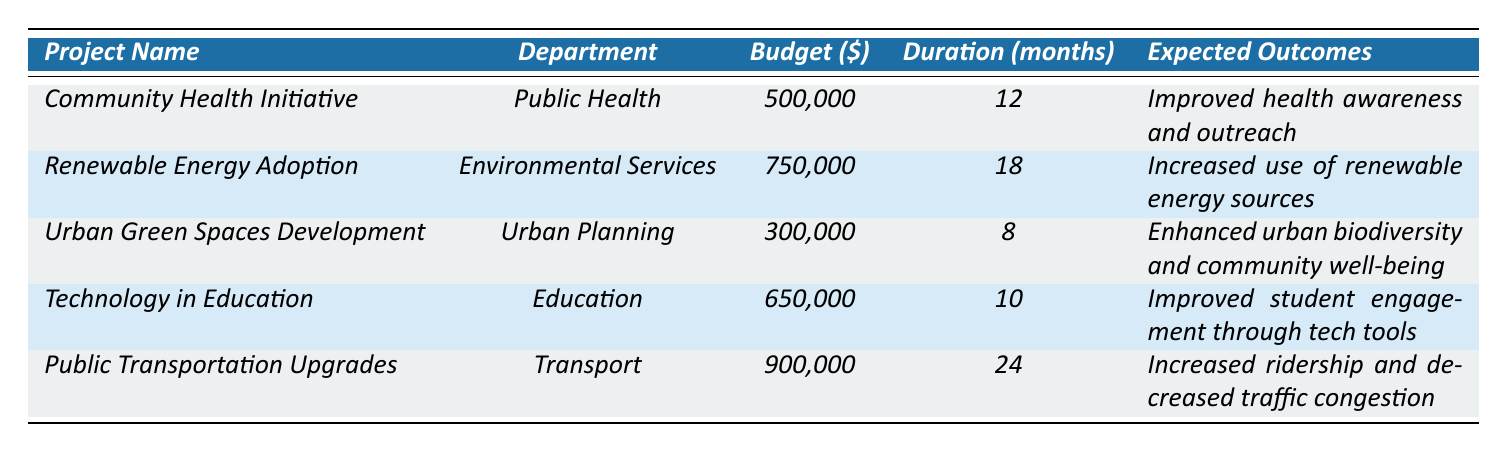What is the budget allocation for the "Urban Green Spaces Development" project? The table explicitly lists the budget allocated to the "Urban Green Spaces Development" project, which is 300,000.
Answer: 300,000 Which project has the longest duration? The duration for each project is listed, with "Public Transportation Upgrades" having a duration of 24 months, which is longer than any other project.
Answer: Public Transportation Upgrades How much total budget was allocated across all projects? To find the total budget, we sum up all the individual budget allocations: 500,000 + 750,000 + 300,000 + 650,000 + 900,000 = 3,100,000.
Answer: 3,100,000 Which department has allocated the highest budget for its project? By comparing the budget allocations, the "Transport" department has the highest budget for the "Public Transportation Upgrades" project at 900,000, more than any other department.
Answer: Transport Is the expected outcome of "Improved health awareness and outreach" associated with any project in the Public Health department? Yes, the "Community Health Initiative" project under the Public Health department has the expected outcome of "Improved health awareness and outreach."
Answer: Yes What is the average budget allocation for all projects? First, we sum the budget allocations (3,100,000). There are 5 projects, so the average is 3,100,000 / 5 = 620,000.
Answer: 620,000 Are there any projects with an expected outcome related to education? Yes, the "Technology in Education" project has an expected outcome of "Improved student engagement through tech tools," which is directly related to education.
Answer: Yes What project has the second highest budget allocation and what is its expected outcome? The project with the second highest budget is "Renewable Energy Adoption" with a budget allocation of 750,000, and its expected outcome is "Increased use of renewable energy sources."
Answer: Renewable Energy Adoption, Increased use of renewable energy sources How many projects are expected to have a duration of less than 12 months? Looking through the duration of each project, only the "Urban Green Spaces Development" has a duration of 8 months, which is less than 12 months, making it 1 project.
Answer: 1 What is the total budget allocation for projects related to health and education departments? The projects are "Community Health Initiative" (500,000) and "Technology in Education" (650,000). Adding these together gives us 500,000 + 650,000 = 1,150,000.
Answer: 1,150,000 